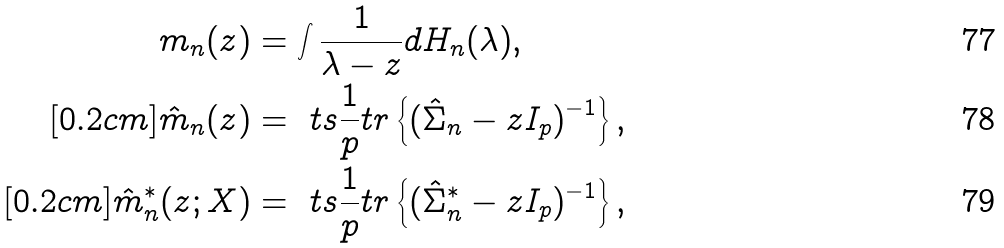<formula> <loc_0><loc_0><loc_500><loc_500>m _ { n } ( z ) & = \int \frac { 1 } { \lambda - z } d H _ { n } ( \lambda ) , \\ [ 0 . 2 c m ] \hat { m } _ { n } ( z ) & = \ t s \frac { 1 } { p } t r \left \{ ( \hat { \Sigma } _ { n } - z I _ { p } ) ^ { - 1 } \right \} , \\ [ 0 . 2 c m ] \hat { m } _ { n } ^ { * } ( z ; X ) & = \ t s \frac { 1 } { p } t r \left \{ ( \hat { \Sigma } _ { n } ^ { * } - z I _ { p } ) ^ { - 1 } \right \} ,</formula> 